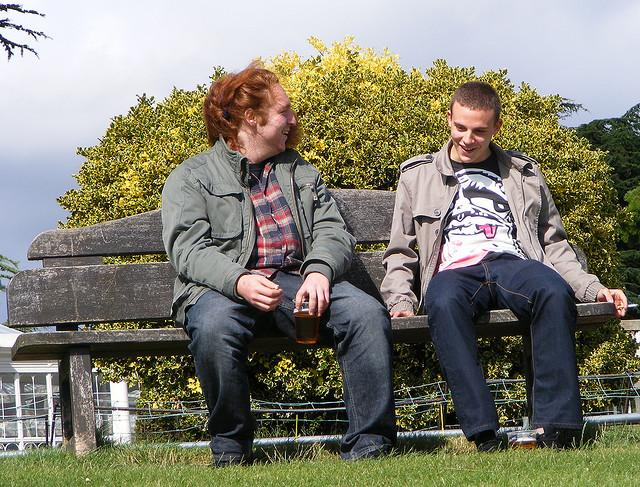What are the men sitting on? bench 